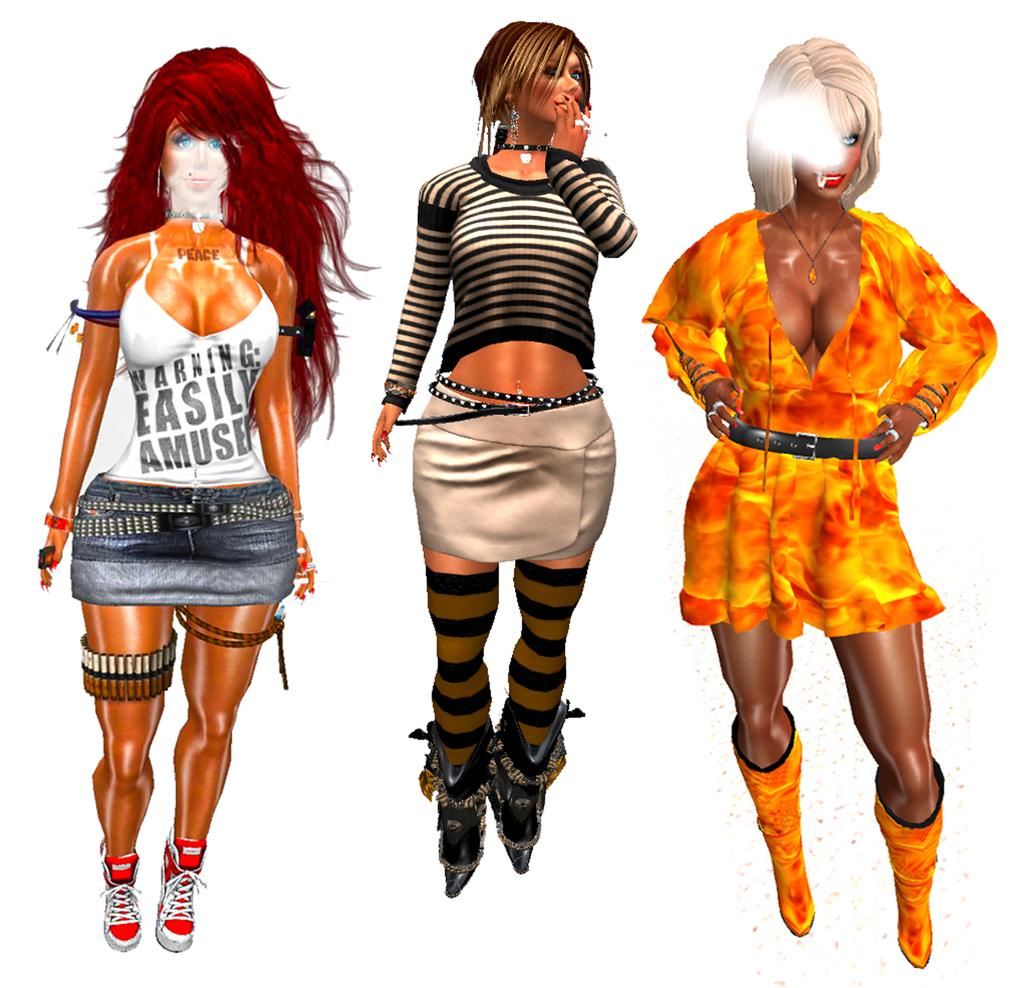<image>
Present a compact description of the photo's key features. a lady that had the word easily written on her shirt 